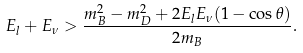Convert formula to latex. <formula><loc_0><loc_0><loc_500><loc_500>E _ { l } + E _ { \nu } > \frac { m _ { B } ^ { 2 } - m _ { D } ^ { 2 } + 2 E _ { l } E _ { \nu } ( 1 - \cos \theta ) } { 2 m _ { B } } .</formula> 